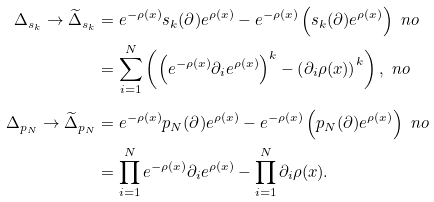Convert formula to latex. <formula><loc_0><loc_0><loc_500><loc_500>\Delta _ { s _ { k } } \to { \widetilde { \Delta } } _ { s _ { k } } & = e ^ { - \rho ( x ) } s _ { k } ( \partial ) e ^ { \rho ( x ) } - e ^ { - \rho ( x ) } \left ( s _ { k } ( \partial ) e ^ { \rho ( x ) } \right ) \ n o \\ & = \sum _ { i = 1 } ^ { N } \left ( \left ( e ^ { - \rho ( x ) } \partial _ { i } e ^ { \rho ( x ) } \right ) ^ { k } - \left ( \partial _ { i } \rho ( x ) \right ) ^ { k } \right ) , \ n o \\ \Delta _ { p _ { N } } \to { \widetilde { \Delta } } _ { p _ { N } } & = e ^ { - \rho ( x ) } p _ { N } ( \partial ) e ^ { \rho ( x ) } - e ^ { - \rho ( x ) } \left ( p _ { N } ( \partial ) e ^ { \rho ( x ) } \right ) \ n o \\ & = \prod _ { i = 1 } ^ { N } e ^ { - \rho ( x ) } \partial _ { i } e ^ { \rho ( x ) } - \prod _ { i = 1 } ^ { N } \partial _ { i } \rho ( x ) .</formula> 